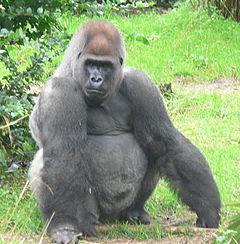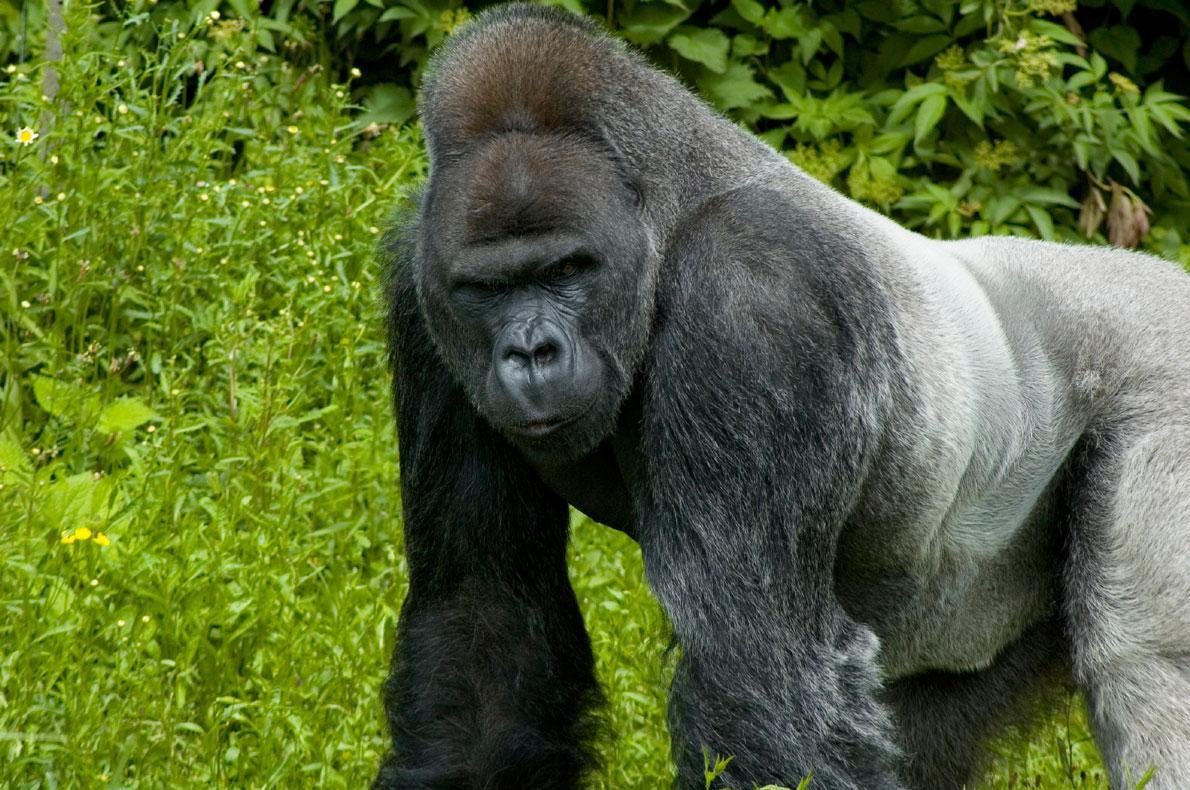The first image is the image on the left, the second image is the image on the right. Considering the images on both sides, is "A single primate is hunched over on all fours in the grass in each image." valid? Answer yes or no. No. The first image is the image on the left, the second image is the image on the right. For the images shown, is this caption "All gorillas are standing on all fours, and no image contains more than one gorilla." true? Answer yes or no. No. 